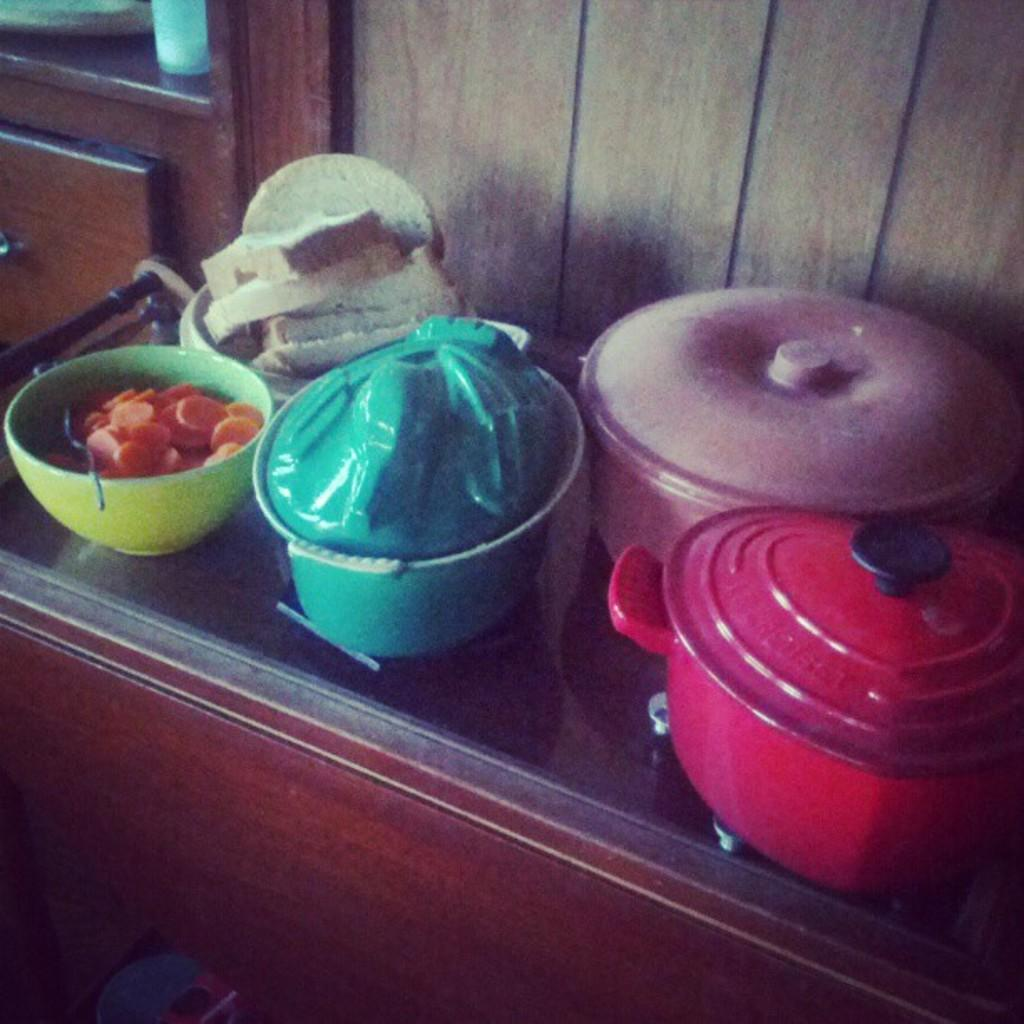What objects are present on the table in the image? There are bowls and vessels placed on a table in the image. What are the bowls and vessels used for? The bowls and vessels are used for holding food items. Can you describe the contents of the bowls and vessels? Yes, there are food items in the bowls and vessels. What is the chance of the bowls and vessels swinging on a step in the image? There is no mention of a step or swinging in the image, and the bowls and vessels are placed on a table. 